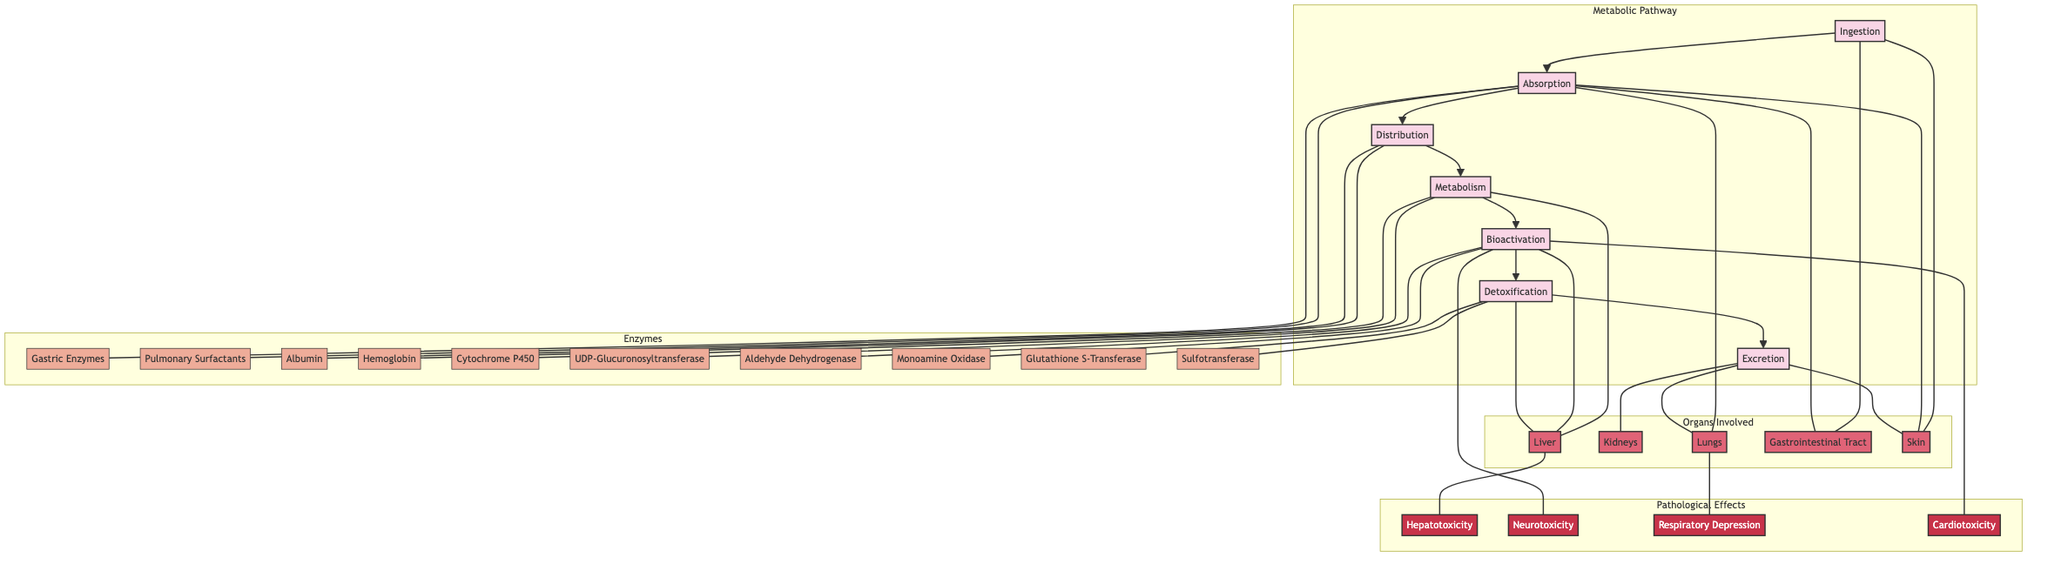What is the first phase in the metabolic pathway? The diagram indicates the first phase by showing "Ingestion" as the initial step leading to subsequent phases.
Answer: Ingestion How many enzymes are involved in the Absorption phase? The diagram lists "Gastric Enzymes" and "Pulmonary Surfactants" as the two enzymes linked to the Absorption phase.
Answer: 2 Which organ is primarily responsible for the Metabolism phase? The pathway shows that "Metabolism" is primarily linked to the "Liver," indicating its primary role in this phase of the alchemical substances.
Answer: Liver What are the pathological effects associated with Bioactivation? The diagram connects "Bioactivation" to "Neurotoxicity" and "Cardiotoxicity," identifying these as issues arising from this phase.
Answer: Neurotoxicity, Cardiotoxicity What is the last phase in the diagram? The flowchart presents "Excretion" as the final step in the metabolic pathway, demonstrating the conclusion of the process.
Answer: Excretion Which two enzymes are linked to the Detoxification phase? The diagram identifies "Glutathione S-Transferase" and "Sulfotransferase" spent in the Detoxification phase.
Answer: Glutathione S-Transferase, Sulfotransferase How do active metabolites affect the nervous system? The pathway indicates that the active metabolites converted during "Bioactivation" lead to "Neurotoxicity," which affects the nervous system negatively.
Answer: Neurotoxicity What is the relationship between Excretion and the Kidneys? The flowchart shows a direct link between "Excretion" and "Kidneys," indicating that the kidneys are involved in the excretion of metabolites.
Answer: Direct link How many organs are involved in the metabolic pathway? The diagram lists five different organs involved, each linked to various phases and functions of the pathway.
Answer: 5 